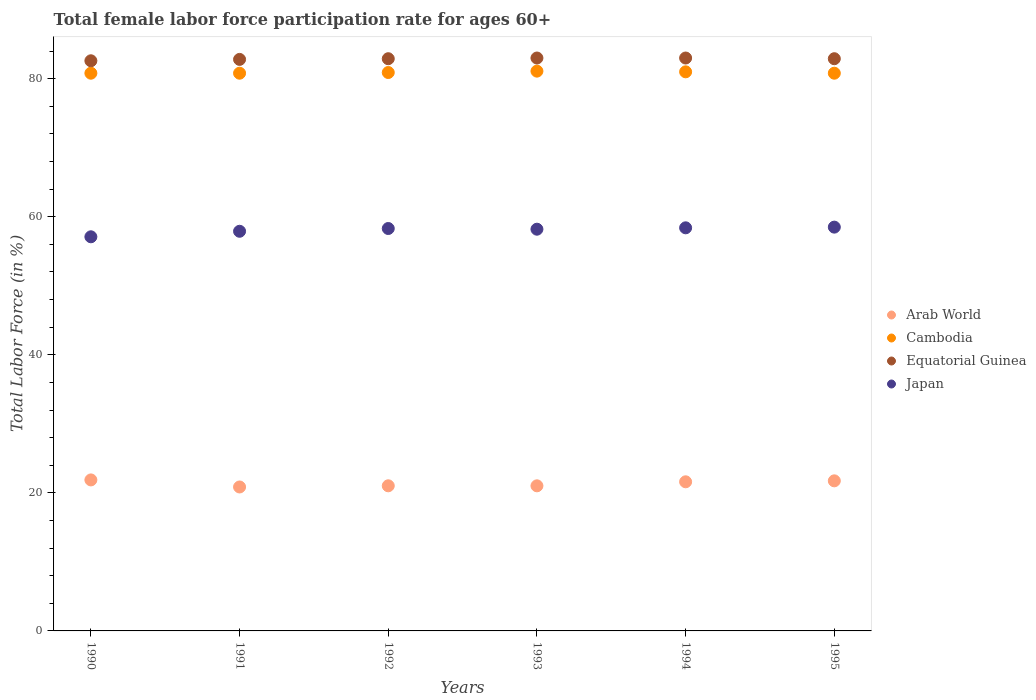Is the number of dotlines equal to the number of legend labels?
Make the answer very short. Yes. What is the female labor force participation rate in Cambodia in 1994?
Provide a succinct answer. 81. Across all years, what is the maximum female labor force participation rate in Cambodia?
Keep it short and to the point. 81.1. Across all years, what is the minimum female labor force participation rate in Arab World?
Your response must be concise. 20.85. In which year was the female labor force participation rate in Cambodia minimum?
Your answer should be very brief. 1990. What is the total female labor force participation rate in Cambodia in the graph?
Make the answer very short. 485.4. What is the difference between the female labor force participation rate in Japan in 1990 and that in 1993?
Keep it short and to the point. -1.1. What is the difference between the female labor force participation rate in Japan in 1991 and the female labor force participation rate in Equatorial Guinea in 1990?
Make the answer very short. -24.7. What is the average female labor force participation rate in Equatorial Guinea per year?
Offer a terse response. 82.87. In the year 1990, what is the difference between the female labor force participation rate in Arab World and female labor force participation rate in Cambodia?
Ensure brevity in your answer.  -58.92. What is the ratio of the female labor force participation rate in Cambodia in 1991 to that in 1994?
Your answer should be compact. 1. Is the difference between the female labor force participation rate in Arab World in 1990 and 1992 greater than the difference between the female labor force participation rate in Cambodia in 1990 and 1992?
Ensure brevity in your answer.  Yes. What is the difference between the highest and the second highest female labor force participation rate in Equatorial Guinea?
Offer a very short reply. 0. What is the difference between the highest and the lowest female labor force participation rate in Cambodia?
Make the answer very short. 0.3. Is the sum of the female labor force participation rate in Equatorial Guinea in 1990 and 1994 greater than the maximum female labor force participation rate in Arab World across all years?
Keep it short and to the point. Yes. Is it the case that in every year, the sum of the female labor force participation rate in Cambodia and female labor force participation rate in Japan  is greater than the sum of female labor force participation rate in Arab World and female labor force participation rate in Equatorial Guinea?
Provide a succinct answer. No. Is it the case that in every year, the sum of the female labor force participation rate in Japan and female labor force participation rate in Arab World  is greater than the female labor force participation rate in Equatorial Guinea?
Ensure brevity in your answer.  No. Does the female labor force participation rate in Cambodia monotonically increase over the years?
Offer a terse response. No. Is the female labor force participation rate in Cambodia strictly less than the female labor force participation rate in Arab World over the years?
Offer a terse response. No. Does the graph contain any zero values?
Your response must be concise. No. Does the graph contain grids?
Offer a very short reply. No. How many legend labels are there?
Your answer should be very brief. 4. How are the legend labels stacked?
Offer a terse response. Vertical. What is the title of the graph?
Give a very brief answer. Total female labor force participation rate for ages 60+. What is the label or title of the X-axis?
Your response must be concise. Years. What is the Total Labor Force (in %) of Arab World in 1990?
Make the answer very short. 21.88. What is the Total Labor Force (in %) of Cambodia in 1990?
Your answer should be compact. 80.8. What is the Total Labor Force (in %) in Equatorial Guinea in 1990?
Offer a very short reply. 82.6. What is the Total Labor Force (in %) of Japan in 1990?
Your answer should be very brief. 57.1. What is the Total Labor Force (in %) of Arab World in 1991?
Provide a succinct answer. 20.85. What is the Total Labor Force (in %) of Cambodia in 1991?
Offer a terse response. 80.8. What is the Total Labor Force (in %) of Equatorial Guinea in 1991?
Keep it short and to the point. 82.8. What is the Total Labor Force (in %) in Japan in 1991?
Give a very brief answer. 57.9. What is the Total Labor Force (in %) in Arab World in 1992?
Provide a succinct answer. 21.02. What is the Total Labor Force (in %) in Cambodia in 1992?
Offer a terse response. 80.9. What is the Total Labor Force (in %) of Equatorial Guinea in 1992?
Your response must be concise. 82.9. What is the Total Labor Force (in %) in Japan in 1992?
Provide a succinct answer. 58.3. What is the Total Labor Force (in %) in Arab World in 1993?
Your answer should be very brief. 21.02. What is the Total Labor Force (in %) in Cambodia in 1993?
Offer a very short reply. 81.1. What is the Total Labor Force (in %) of Equatorial Guinea in 1993?
Provide a succinct answer. 83. What is the Total Labor Force (in %) of Japan in 1993?
Offer a terse response. 58.2. What is the Total Labor Force (in %) of Arab World in 1994?
Your answer should be compact. 21.6. What is the Total Labor Force (in %) in Cambodia in 1994?
Make the answer very short. 81. What is the Total Labor Force (in %) in Equatorial Guinea in 1994?
Ensure brevity in your answer.  83. What is the Total Labor Force (in %) in Japan in 1994?
Provide a succinct answer. 58.4. What is the Total Labor Force (in %) of Arab World in 1995?
Ensure brevity in your answer.  21.74. What is the Total Labor Force (in %) of Cambodia in 1995?
Provide a succinct answer. 80.8. What is the Total Labor Force (in %) of Equatorial Guinea in 1995?
Provide a short and direct response. 82.9. What is the Total Labor Force (in %) in Japan in 1995?
Give a very brief answer. 58.5. Across all years, what is the maximum Total Labor Force (in %) in Arab World?
Make the answer very short. 21.88. Across all years, what is the maximum Total Labor Force (in %) of Cambodia?
Ensure brevity in your answer.  81.1. Across all years, what is the maximum Total Labor Force (in %) of Equatorial Guinea?
Your answer should be compact. 83. Across all years, what is the maximum Total Labor Force (in %) of Japan?
Provide a succinct answer. 58.5. Across all years, what is the minimum Total Labor Force (in %) of Arab World?
Ensure brevity in your answer.  20.85. Across all years, what is the minimum Total Labor Force (in %) in Cambodia?
Offer a very short reply. 80.8. Across all years, what is the minimum Total Labor Force (in %) in Equatorial Guinea?
Make the answer very short. 82.6. Across all years, what is the minimum Total Labor Force (in %) of Japan?
Offer a very short reply. 57.1. What is the total Total Labor Force (in %) of Arab World in the graph?
Offer a terse response. 128.13. What is the total Total Labor Force (in %) in Cambodia in the graph?
Give a very brief answer. 485.4. What is the total Total Labor Force (in %) of Equatorial Guinea in the graph?
Offer a terse response. 497.2. What is the total Total Labor Force (in %) in Japan in the graph?
Your answer should be very brief. 348.4. What is the difference between the Total Labor Force (in %) of Arab World in 1990 and that in 1991?
Provide a short and direct response. 1.02. What is the difference between the Total Labor Force (in %) in Arab World in 1990 and that in 1992?
Ensure brevity in your answer.  0.85. What is the difference between the Total Labor Force (in %) in Cambodia in 1990 and that in 1992?
Ensure brevity in your answer.  -0.1. What is the difference between the Total Labor Force (in %) of Arab World in 1990 and that in 1993?
Your answer should be very brief. 0.86. What is the difference between the Total Labor Force (in %) of Cambodia in 1990 and that in 1993?
Your answer should be very brief. -0.3. What is the difference between the Total Labor Force (in %) in Arab World in 1990 and that in 1994?
Provide a short and direct response. 0.27. What is the difference between the Total Labor Force (in %) in Equatorial Guinea in 1990 and that in 1994?
Your response must be concise. -0.4. What is the difference between the Total Labor Force (in %) of Japan in 1990 and that in 1994?
Make the answer very short. -1.3. What is the difference between the Total Labor Force (in %) of Arab World in 1990 and that in 1995?
Provide a succinct answer. 0.13. What is the difference between the Total Labor Force (in %) of Cambodia in 1990 and that in 1995?
Give a very brief answer. 0. What is the difference between the Total Labor Force (in %) of Equatorial Guinea in 1990 and that in 1995?
Give a very brief answer. -0.3. What is the difference between the Total Labor Force (in %) in Japan in 1990 and that in 1995?
Your response must be concise. -1.4. What is the difference between the Total Labor Force (in %) of Arab World in 1991 and that in 1992?
Your answer should be compact. -0.17. What is the difference between the Total Labor Force (in %) of Arab World in 1991 and that in 1993?
Your response must be concise. -0.17. What is the difference between the Total Labor Force (in %) in Cambodia in 1991 and that in 1993?
Offer a terse response. -0.3. What is the difference between the Total Labor Force (in %) in Japan in 1991 and that in 1993?
Your answer should be very brief. -0.3. What is the difference between the Total Labor Force (in %) in Arab World in 1991 and that in 1994?
Provide a short and direct response. -0.75. What is the difference between the Total Labor Force (in %) of Arab World in 1991 and that in 1995?
Provide a short and direct response. -0.89. What is the difference between the Total Labor Force (in %) of Cambodia in 1991 and that in 1995?
Your answer should be very brief. 0. What is the difference between the Total Labor Force (in %) of Arab World in 1992 and that in 1993?
Offer a very short reply. 0. What is the difference between the Total Labor Force (in %) of Cambodia in 1992 and that in 1993?
Offer a very short reply. -0.2. What is the difference between the Total Labor Force (in %) of Equatorial Guinea in 1992 and that in 1993?
Keep it short and to the point. -0.1. What is the difference between the Total Labor Force (in %) of Arab World in 1992 and that in 1994?
Provide a succinct answer. -0.58. What is the difference between the Total Labor Force (in %) in Japan in 1992 and that in 1994?
Your response must be concise. -0.1. What is the difference between the Total Labor Force (in %) in Arab World in 1992 and that in 1995?
Your answer should be very brief. -0.72. What is the difference between the Total Labor Force (in %) of Cambodia in 1992 and that in 1995?
Give a very brief answer. 0.1. What is the difference between the Total Labor Force (in %) of Japan in 1992 and that in 1995?
Your response must be concise. -0.2. What is the difference between the Total Labor Force (in %) of Arab World in 1993 and that in 1994?
Offer a very short reply. -0.58. What is the difference between the Total Labor Force (in %) of Japan in 1993 and that in 1994?
Your answer should be compact. -0.2. What is the difference between the Total Labor Force (in %) in Arab World in 1993 and that in 1995?
Offer a very short reply. -0.72. What is the difference between the Total Labor Force (in %) in Equatorial Guinea in 1993 and that in 1995?
Your answer should be very brief. 0.1. What is the difference between the Total Labor Force (in %) in Arab World in 1994 and that in 1995?
Ensure brevity in your answer.  -0.14. What is the difference between the Total Labor Force (in %) in Cambodia in 1994 and that in 1995?
Give a very brief answer. 0.2. What is the difference between the Total Labor Force (in %) of Equatorial Guinea in 1994 and that in 1995?
Ensure brevity in your answer.  0.1. What is the difference between the Total Labor Force (in %) of Japan in 1994 and that in 1995?
Offer a very short reply. -0.1. What is the difference between the Total Labor Force (in %) in Arab World in 1990 and the Total Labor Force (in %) in Cambodia in 1991?
Give a very brief answer. -58.92. What is the difference between the Total Labor Force (in %) in Arab World in 1990 and the Total Labor Force (in %) in Equatorial Guinea in 1991?
Your response must be concise. -60.92. What is the difference between the Total Labor Force (in %) in Arab World in 1990 and the Total Labor Force (in %) in Japan in 1991?
Keep it short and to the point. -36.02. What is the difference between the Total Labor Force (in %) of Cambodia in 1990 and the Total Labor Force (in %) of Equatorial Guinea in 1991?
Provide a succinct answer. -2. What is the difference between the Total Labor Force (in %) in Cambodia in 1990 and the Total Labor Force (in %) in Japan in 1991?
Your answer should be very brief. 22.9. What is the difference between the Total Labor Force (in %) in Equatorial Guinea in 1990 and the Total Labor Force (in %) in Japan in 1991?
Your response must be concise. 24.7. What is the difference between the Total Labor Force (in %) in Arab World in 1990 and the Total Labor Force (in %) in Cambodia in 1992?
Ensure brevity in your answer.  -59.02. What is the difference between the Total Labor Force (in %) of Arab World in 1990 and the Total Labor Force (in %) of Equatorial Guinea in 1992?
Make the answer very short. -61.02. What is the difference between the Total Labor Force (in %) in Arab World in 1990 and the Total Labor Force (in %) in Japan in 1992?
Keep it short and to the point. -36.42. What is the difference between the Total Labor Force (in %) in Equatorial Guinea in 1990 and the Total Labor Force (in %) in Japan in 1992?
Give a very brief answer. 24.3. What is the difference between the Total Labor Force (in %) of Arab World in 1990 and the Total Labor Force (in %) of Cambodia in 1993?
Give a very brief answer. -59.22. What is the difference between the Total Labor Force (in %) in Arab World in 1990 and the Total Labor Force (in %) in Equatorial Guinea in 1993?
Provide a short and direct response. -61.12. What is the difference between the Total Labor Force (in %) in Arab World in 1990 and the Total Labor Force (in %) in Japan in 1993?
Provide a succinct answer. -36.32. What is the difference between the Total Labor Force (in %) of Cambodia in 1990 and the Total Labor Force (in %) of Japan in 1993?
Keep it short and to the point. 22.6. What is the difference between the Total Labor Force (in %) in Equatorial Guinea in 1990 and the Total Labor Force (in %) in Japan in 1993?
Make the answer very short. 24.4. What is the difference between the Total Labor Force (in %) of Arab World in 1990 and the Total Labor Force (in %) of Cambodia in 1994?
Make the answer very short. -59.12. What is the difference between the Total Labor Force (in %) in Arab World in 1990 and the Total Labor Force (in %) in Equatorial Guinea in 1994?
Your answer should be compact. -61.12. What is the difference between the Total Labor Force (in %) of Arab World in 1990 and the Total Labor Force (in %) of Japan in 1994?
Give a very brief answer. -36.52. What is the difference between the Total Labor Force (in %) of Cambodia in 1990 and the Total Labor Force (in %) of Equatorial Guinea in 1994?
Ensure brevity in your answer.  -2.2. What is the difference between the Total Labor Force (in %) of Cambodia in 1990 and the Total Labor Force (in %) of Japan in 1994?
Provide a short and direct response. 22.4. What is the difference between the Total Labor Force (in %) in Equatorial Guinea in 1990 and the Total Labor Force (in %) in Japan in 1994?
Provide a succinct answer. 24.2. What is the difference between the Total Labor Force (in %) in Arab World in 1990 and the Total Labor Force (in %) in Cambodia in 1995?
Your answer should be compact. -58.92. What is the difference between the Total Labor Force (in %) in Arab World in 1990 and the Total Labor Force (in %) in Equatorial Guinea in 1995?
Give a very brief answer. -61.02. What is the difference between the Total Labor Force (in %) of Arab World in 1990 and the Total Labor Force (in %) of Japan in 1995?
Your answer should be very brief. -36.62. What is the difference between the Total Labor Force (in %) of Cambodia in 1990 and the Total Labor Force (in %) of Equatorial Guinea in 1995?
Provide a short and direct response. -2.1. What is the difference between the Total Labor Force (in %) in Cambodia in 1990 and the Total Labor Force (in %) in Japan in 1995?
Your answer should be compact. 22.3. What is the difference between the Total Labor Force (in %) of Equatorial Guinea in 1990 and the Total Labor Force (in %) of Japan in 1995?
Your answer should be very brief. 24.1. What is the difference between the Total Labor Force (in %) in Arab World in 1991 and the Total Labor Force (in %) in Cambodia in 1992?
Your answer should be compact. -60.05. What is the difference between the Total Labor Force (in %) in Arab World in 1991 and the Total Labor Force (in %) in Equatorial Guinea in 1992?
Give a very brief answer. -62.05. What is the difference between the Total Labor Force (in %) in Arab World in 1991 and the Total Labor Force (in %) in Japan in 1992?
Offer a very short reply. -37.45. What is the difference between the Total Labor Force (in %) in Cambodia in 1991 and the Total Labor Force (in %) in Equatorial Guinea in 1992?
Your response must be concise. -2.1. What is the difference between the Total Labor Force (in %) in Cambodia in 1991 and the Total Labor Force (in %) in Japan in 1992?
Keep it short and to the point. 22.5. What is the difference between the Total Labor Force (in %) of Arab World in 1991 and the Total Labor Force (in %) of Cambodia in 1993?
Your answer should be compact. -60.25. What is the difference between the Total Labor Force (in %) of Arab World in 1991 and the Total Labor Force (in %) of Equatorial Guinea in 1993?
Offer a very short reply. -62.15. What is the difference between the Total Labor Force (in %) of Arab World in 1991 and the Total Labor Force (in %) of Japan in 1993?
Provide a short and direct response. -37.35. What is the difference between the Total Labor Force (in %) of Cambodia in 1991 and the Total Labor Force (in %) of Japan in 1993?
Keep it short and to the point. 22.6. What is the difference between the Total Labor Force (in %) of Equatorial Guinea in 1991 and the Total Labor Force (in %) of Japan in 1993?
Ensure brevity in your answer.  24.6. What is the difference between the Total Labor Force (in %) in Arab World in 1991 and the Total Labor Force (in %) in Cambodia in 1994?
Make the answer very short. -60.15. What is the difference between the Total Labor Force (in %) in Arab World in 1991 and the Total Labor Force (in %) in Equatorial Guinea in 1994?
Give a very brief answer. -62.15. What is the difference between the Total Labor Force (in %) in Arab World in 1991 and the Total Labor Force (in %) in Japan in 1994?
Your response must be concise. -37.55. What is the difference between the Total Labor Force (in %) of Cambodia in 1991 and the Total Labor Force (in %) of Equatorial Guinea in 1994?
Your response must be concise. -2.2. What is the difference between the Total Labor Force (in %) in Cambodia in 1991 and the Total Labor Force (in %) in Japan in 1994?
Provide a short and direct response. 22.4. What is the difference between the Total Labor Force (in %) of Equatorial Guinea in 1991 and the Total Labor Force (in %) of Japan in 1994?
Your answer should be very brief. 24.4. What is the difference between the Total Labor Force (in %) in Arab World in 1991 and the Total Labor Force (in %) in Cambodia in 1995?
Ensure brevity in your answer.  -59.95. What is the difference between the Total Labor Force (in %) of Arab World in 1991 and the Total Labor Force (in %) of Equatorial Guinea in 1995?
Keep it short and to the point. -62.05. What is the difference between the Total Labor Force (in %) of Arab World in 1991 and the Total Labor Force (in %) of Japan in 1995?
Ensure brevity in your answer.  -37.65. What is the difference between the Total Labor Force (in %) of Cambodia in 1991 and the Total Labor Force (in %) of Equatorial Guinea in 1995?
Keep it short and to the point. -2.1. What is the difference between the Total Labor Force (in %) of Cambodia in 1991 and the Total Labor Force (in %) of Japan in 1995?
Give a very brief answer. 22.3. What is the difference between the Total Labor Force (in %) of Equatorial Guinea in 1991 and the Total Labor Force (in %) of Japan in 1995?
Provide a short and direct response. 24.3. What is the difference between the Total Labor Force (in %) of Arab World in 1992 and the Total Labor Force (in %) of Cambodia in 1993?
Provide a succinct answer. -60.08. What is the difference between the Total Labor Force (in %) of Arab World in 1992 and the Total Labor Force (in %) of Equatorial Guinea in 1993?
Offer a terse response. -61.98. What is the difference between the Total Labor Force (in %) of Arab World in 1992 and the Total Labor Force (in %) of Japan in 1993?
Provide a short and direct response. -37.18. What is the difference between the Total Labor Force (in %) in Cambodia in 1992 and the Total Labor Force (in %) in Japan in 1993?
Keep it short and to the point. 22.7. What is the difference between the Total Labor Force (in %) in Equatorial Guinea in 1992 and the Total Labor Force (in %) in Japan in 1993?
Keep it short and to the point. 24.7. What is the difference between the Total Labor Force (in %) of Arab World in 1992 and the Total Labor Force (in %) of Cambodia in 1994?
Your answer should be very brief. -59.98. What is the difference between the Total Labor Force (in %) in Arab World in 1992 and the Total Labor Force (in %) in Equatorial Guinea in 1994?
Provide a short and direct response. -61.98. What is the difference between the Total Labor Force (in %) of Arab World in 1992 and the Total Labor Force (in %) of Japan in 1994?
Provide a short and direct response. -37.38. What is the difference between the Total Labor Force (in %) of Cambodia in 1992 and the Total Labor Force (in %) of Equatorial Guinea in 1994?
Your answer should be compact. -2.1. What is the difference between the Total Labor Force (in %) in Arab World in 1992 and the Total Labor Force (in %) in Cambodia in 1995?
Ensure brevity in your answer.  -59.78. What is the difference between the Total Labor Force (in %) in Arab World in 1992 and the Total Labor Force (in %) in Equatorial Guinea in 1995?
Give a very brief answer. -61.88. What is the difference between the Total Labor Force (in %) in Arab World in 1992 and the Total Labor Force (in %) in Japan in 1995?
Ensure brevity in your answer.  -37.48. What is the difference between the Total Labor Force (in %) in Cambodia in 1992 and the Total Labor Force (in %) in Equatorial Guinea in 1995?
Your answer should be compact. -2. What is the difference between the Total Labor Force (in %) of Cambodia in 1992 and the Total Labor Force (in %) of Japan in 1995?
Give a very brief answer. 22.4. What is the difference between the Total Labor Force (in %) in Equatorial Guinea in 1992 and the Total Labor Force (in %) in Japan in 1995?
Keep it short and to the point. 24.4. What is the difference between the Total Labor Force (in %) of Arab World in 1993 and the Total Labor Force (in %) of Cambodia in 1994?
Offer a very short reply. -59.98. What is the difference between the Total Labor Force (in %) in Arab World in 1993 and the Total Labor Force (in %) in Equatorial Guinea in 1994?
Give a very brief answer. -61.98. What is the difference between the Total Labor Force (in %) in Arab World in 1993 and the Total Labor Force (in %) in Japan in 1994?
Offer a terse response. -37.38. What is the difference between the Total Labor Force (in %) of Cambodia in 1993 and the Total Labor Force (in %) of Japan in 1994?
Provide a succinct answer. 22.7. What is the difference between the Total Labor Force (in %) of Equatorial Guinea in 1993 and the Total Labor Force (in %) of Japan in 1994?
Ensure brevity in your answer.  24.6. What is the difference between the Total Labor Force (in %) in Arab World in 1993 and the Total Labor Force (in %) in Cambodia in 1995?
Offer a very short reply. -59.78. What is the difference between the Total Labor Force (in %) in Arab World in 1993 and the Total Labor Force (in %) in Equatorial Guinea in 1995?
Provide a short and direct response. -61.88. What is the difference between the Total Labor Force (in %) of Arab World in 1993 and the Total Labor Force (in %) of Japan in 1995?
Make the answer very short. -37.48. What is the difference between the Total Labor Force (in %) of Cambodia in 1993 and the Total Labor Force (in %) of Equatorial Guinea in 1995?
Give a very brief answer. -1.8. What is the difference between the Total Labor Force (in %) of Cambodia in 1993 and the Total Labor Force (in %) of Japan in 1995?
Give a very brief answer. 22.6. What is the difference between the Total Labor Force (in %) of Equatorial Guinea in 1993 and the Total Labor Force (in %) of Japan in 1995?
Give a very brief answer. 24.5. What is the difference between the Total Labor Force (in %) of Arab World in 1994 and the Total Labor Force (in %) of Cambodia in 1995?
Provide a succinct answer. -59.2. What is the difference between the Total Labor Force (in %) in Arab World in 1994 and the Total Labor Force (in %) in Equatorial Guinea in 1995?
Ensure brevity in your answer.  -61.3. What is the difference between the Total Labor Force (in %) in Arab World in 1994 and the Total Labor Force (in %) in Japan in 1995?
Your answer should be very brief. -36.9. What is the difference between the Total Labor Force (in %) in Cambodia in 1994 and the Total Labor Force (in %) in Japan in 1995?
Your answer should be compact. 22.5. What is the difference between the Total Labor Force (in %) in Equatorial Guinea in 1994 and the Total Labor Force (in %) in Japan in 1995?
Your answer should be compact. 24.5. What is the average Total Labor Force (in %) of Arab World per year?
Offer a terse response. 21.35. What is the average Total Labor Force (in %) of Cambodia per year?
Provide a short and direct response. 80.9. What is the average Total Labor Force (in %) in Equatorial Guinea per year?
Offer a very short reply. 82.87. What is the average Total Labor Force (in %) in Japan per year?
Make the answer very short. 58.07. In the year 1990, what is the difference between the Total Labor Force (in %) in Arab World and Total Labor Force (in %) in Cambodia?
Keep it short and to the point. -58.92. In the year 1990, what is the difference between the Total Labor Force (in %) in Arab World and Total Labor Force (in %) in Equatorial Guinea?
Provide a short and direct response. -60.72. In the year 1990, what is the difference between the Total Labor Force (in %) in Arab World and Total Labor Force (in %) in Japan?
Offer a very short reply. -35.22. In the year 1990, what is the difference between the Total Labor Force (in %) in Cambodia and Total Labor Force (in %) in Japan?
Offer a terse response. 23.7. In the year 1991, what is the difference between the Total Labor Force (in %) of Arab World and Total Labor Force (in %) of Cambodia?
Provide a succinct answer. -59.95. In the year 1991, what is the difference between the Total Labor Force (in %) of Arab World and Total Labor Force (in %) of Equatorial Guinea?
Provide a succinct answer. -61.95. In the year 1991, what is the difference between the Total Labor Force (in %) in Arab World and Total Labor Force (in %) in Japan?
Ensure brevity in your answer.  -37.05. In the year 1991, what is the difference between the Total Labor Force (in %) of Cambodia and Total Labor Force (in %) of Equatorial Guinea?
Make the answer very short. -2. In the year 1991, what is the difference between the Total Labor Force (in %) of Cambodia and Total Labor Force (in %) of Japan?
Give a very brief answer. 22.9. In the year 1991, what is the difference between the Total Labor Force (in %) in Equatorial Guinea and Total Labor Force (in %) in Japan?
Offer a terse response. 24.9. In the year 1992, what is the difference between the Total Labor Force (in %) of Arab World and Total Labor Force (in %) of Cambodia?
Make the answer very short. -59.88. In the year 1992, what is the difference between the Total Labor Force (in %) of Arab World and Total Labor Force (in %) of Equatorial Guinea?
Offer a very short reply. -61.88. In the year 1992, what is the difference between the Total Labor Force (in %) in Arab World and Total Labor Force (in %) in Japan?
Provide a short and direct response. -37.28. In the year 1992, what is the difference between the Total Labor Force (in %) in Cambodia and Total Labor Force (in %) in Japan?
Provide a short and direct response. 22.6. In the year 1992, what is the difference between the Total Labor Force (in %) of Equatorial Guinea and Total Labor Force (in %) of Japan?
Your answer should be compact. 24.6. In the year 1993, what is the difference between the Total Labor Force (in %) in Arab World and Total Labor Force (in %) in Cambodia?
Make the answer very short. -60.08. In the year 1993, what is the difference between the Total Labor Force (in %) in Arab World and Total Labor Force (in %) in Equatorial Guinea?
Ensure brevity in your answer.  -61.98. In the year 1993, what is the difference between the Total Labor Force (in %) in Arab World and Total Labor Force (in %) in Japan?
Your answer should be very brief. -37.18. In the year 1993, what is the difference between the Total Labor Force (in %) of Cambodia and Total Labor Force (in %) of Japan?
Keep it short and to the point. 22.9. In the year 1993, what is the difference between the Total Labor Force (in %) of Equatorial Guinea and Total Labor Force (in %) of Japan?
Offer a very short reply. 24.8. In the year 1994, what is the difference between the Total Labor Force (in %) in Arab World and Total Labor Force (in %) in Cambodia?
Offer a very short reply. -59.4. In the year 1994, what is the difference between the Total Labor Force (in %) of Arab World and Total Labor Force (in %) of Equatorial Guinea?
Offer a terse response. -61.4. In the year 1994, what is the difference between the Total Labor Force (in %) in Arab World and Total Labor Force (in %) in Japan?
Offer a very short reply. -36.8. In the year 1994, what is the difference between the Total Labor Force (in %) in Cambodia and Total Labor Force (in %) in Japan?
Offer a terse response. 22.6. In the year 1994, what is the difference between the Total Labor Force (in %) of Equatorial Guinea and Total Labor Force (in %) of Japan?
Ensure brevity in your answer.  24.6. In the year 1995, what is the difference between the Total Labor Force (in %) of Arab World and Total Labor Force (in %) of Cambodia?
Your answer should be very brief. -59.06. In the year 1995, what is the difference between the Total Labor Force (in %) in Arab World and Total Labor Force (in %) in Equatorial Guinea?
Give a very brief answer. -61.16. In the year 1995, what is the difference between the Total Labor Force (in %) of Arab World and Total Labor Force (in %) of Japan?
Keep it short and to the point. -36.76. In the year 1995, what is the difference between the Total Labor Force (in %) in Cambodia and Total Labor Force (in %) in Japan?
Your answer should be compact. 22.3. In the year 1995, what is the difference between the Total Labor Force (in %) in Equatorial Guinea and Total Labor Force (in %) in Japan?
Keep it short and to the point. 24.4. What is the ratio of the Total Labor Force (in %) in Arab World in 1990 to that in 1991?
Provide a short and direct response. 1.05. What is the ratio of the Total Labor Force (in %) of Equatorial Guinea in 1990 to that in 1991?
Make the answer very short. 1. What is the ratio of the Total Labor Force (in %) of Japan in 1990 to that in 1991?
Your answer should be compact. 0.99. What is the ratio of the Total Labor Force (in %) in Arab World in 1990 to that in 1992?
Make the answer very short. 1.04. What is the ratio of the Total Labor Force (in %) in Equatorial Guinea in 1990 to that in 1992?
Offer a very short reply. 1. What is the ratio of the Total Labor Force (in %) of Japan in 1990 to that in 1992?
Your answer should be very brief. 0.98. What is the ratio of the Total Labor Force (in %) in Arab World in 1990 to that in 1993?
Make the answer very short. 1.04. What is the ratio of the Total Labor Force (in %) of Cambodia in 1990 to that in 1993?
Offer a very short reply. 1. What is the ratio of the Total Labor Force (in %) in Equatorial Guinea in 1990 to that in 1993?
Keep it short and to the point. 1. What is the ratio of the Total Labor Force (in %) in Japan in 1990 to that in 1993?
Your response must be concise. 0.98. What is the ratio of the Total Labor Force (in %) in Arab World in 1990 to that in 1994?
Your answer should be very brief. 1.01. What is the ratio of the Total Labor Force (in %) of Equatorial Guinea in 1990 to that in 1994?
Keep it short and to the point. 1. What is the ratio of the Total Labor Force (in %) in Japan in 1990 to that in 1994?
Provide a short and direct response. 0.98. What is the ratio of the Total Labor Force (in %) in Japan in 1990 to that in 1995?
Your answer should be very brief. 0.98. What is the ratio of the Total Labor Force (in %) in Cambodia in 1991 to that in 1992?
Offer a very short reply. 1. What is the ratio of the Total Labor Force (in %) of Equatorial Guinea in 1991 to that in 1992?
Your response must be concise. 1. What is the ratio of the Total Labor Force (in %) of Arab World in 1991 to that in 1993?
Offer a very short reply. 0.99. What is the ratio of the Total Labor Force (in %) in Cambodia in 1991 to that in 1993?
Make the answer very short. 1. What is the ratio of the Total Labor Force (in %) in Japan in 1991 to that in 1993?
Provide a short and direct response. 0.99. What is the ratio of the Total Labor Force (in %) in Arab World in 1991 to that in 1994?
Provide a succinct answer. 0.97. What is the ratio of the Total Labor Force (in %) in Cambodia in 1991 to that in 1994?
Offer a terse response. 1. What is the ratio of the Total Labor Force (in %) of Equatorial Guinea in 1991 to that in 1994?
Give a very brief answer. 1. What is the ratio of the Total Labor Force (in %) of Japan in 1991 to that in 1994?
Offer a terse response. 0.99. What is the ratio of the Total Labor Force (in %) of Arab World in 1991 to that in 1995?
Your response must be concise. 0.96. What is the ratio of the Total Labor Force (in %) of Cambodia in 1991 to that in 1995?
Offer a terse response. 1. What is the ratio of the Total Labor Force (in %) in Japan in 1991 to that in 1995?
Make the answer very short. 0.99. What is the ratio of the Total Labor Force (in %) of Arab World in 1992 to that in 1993?
Keep it short and to the point. 1. What is the ratio of the Total Labor Force (in %) of Cambodia in 1992 to that in 1993?
Provide a short and direct response. 1. What is the ratio of the Total Labor Force (in %) of Arab World in 1992 to that in 1994?
Make the answer very short. 0.97. What is the ratio of the Total Labor Force (in %) in Equatorial Guinea in 1992 to that in 1994?
Offer a terse response. 1. What is the ratio of the Total Labor Force (in %) of Arab World in 1992 to that in 1995?
Provide a succinct answer. 0.97. What is the ratio of the Total Labor Force (in %) in Cambodia in 1992 to that in 1995?
Provide a short and direct response. 1. What is the ratio of the Total Labor Force (in %) of Japan in 1992 to that in 1995?
Ensure brevity in your answer.  1. What is the ratio of the Total Labor Force (in %) in Equatorial Guinea in 1993 to that in 1994?
Your answer should be compact. 1. What is the ratio of the Total Labor Force (in %) in Japan in 1993 to that in 1994?
Keep it short and to the point. 1. What is the ratio of the Total Labor Force (in %) in Arab World in 1993 to that in 1995?
Offer a terse response. 0.97. What is the ratio of the Total Labor Force (in %) in Equatorial Guinea in 1993 to that in 1995?
Provide a short and direct response. 1. What is the difference between the highest and the second highest Total Labor Force (in %) of Arab World?
Offer a very short reply. 0.13. What is the difference between the highest and the second highest Total Labor Force (in %) in Cambodia?
Provide a succinct answer. 0.1. What is the difference between the highest and the second highest Total Labor Force (in %) of Japan?
Your answer should be very brief. 0.1. What is the difference between the highest and the lowest Total Labor Force (in %) of Arab World?
Your answer should be very brief. 1.02. What is the difference between the highest and the lowest Total Labor Force (in %) of Equatorial Guinea?
Give a very brief answer. 0.4. 